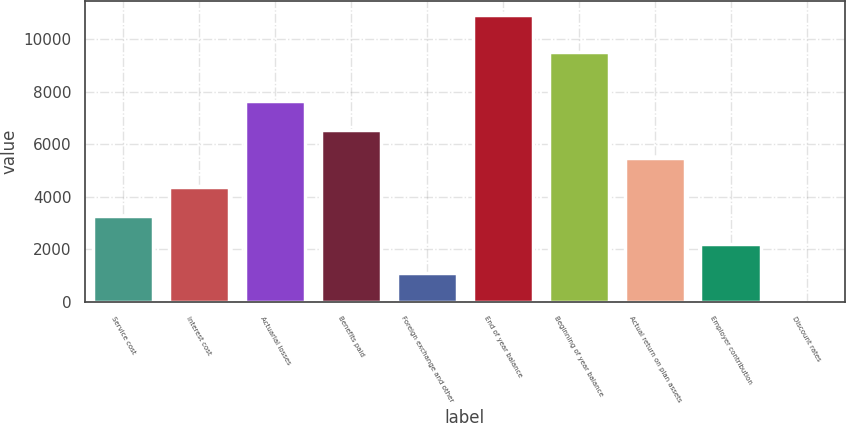<chart> <loc_0><loc_0><loc_500><loc_500><bar_chart><fcel>Service cost<fcel>Interest cost<fcel>Actuarial losses<fcel>Benefits paid<fcel>Foreign exchange and other<fcel>End of year balance<fcel>Beginning of year balance<fcel>Actual return on plan assets<fcel>Employer contribution<fcel>Discount rates<nl><fcel>3280.58<fcel>4372.64<fcel>7648.82<fcel>6556.76<fcel>1096.46<fcel>10925<fcel>9504<fcel>5464.7<fcel>2188.52<fcel>4.4<nl></chart> 